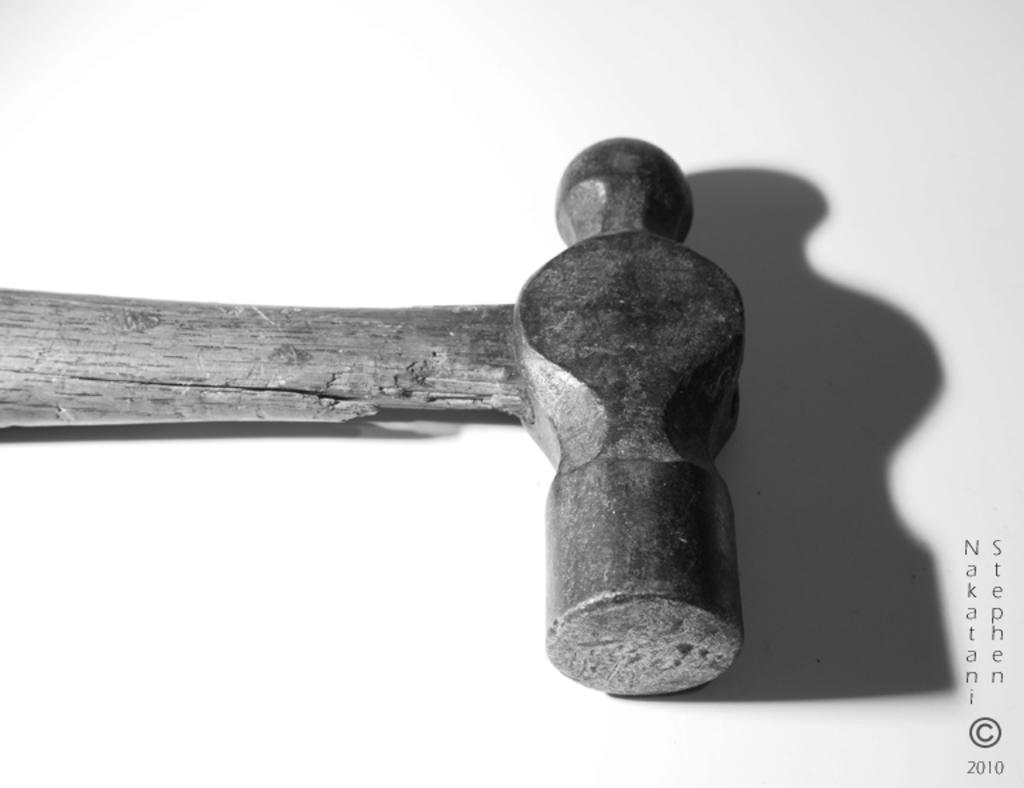What object can be seen in the image? There is a hammer in the image. What else is present in the image besides the hammer? There is text and numbers in the image. Where are the text and numbers located in the image? The text and numbers are located on the bottom right side of the image. What is the color of the background in the image? The background of the image is white. What type of zinc is used to write the text in the image? There is no zinc present in the image, and the text is not written by hand. --- Facts: 1. There is a person sitting on a chair in the image. 2. The person is holding a book. 3. The book has a blue cover. 4. There is a table next to the chair. 5. The table has a lamp on it. Absurd Topics: elephant, ocean, bicycle Conversation: What is the person in the image doing? The person is sitting on a chair in the image. What is the person holding in the image? The person is holding a book in the image. What color is the book's cover? The book has a blue cover. What is located next to the chair in the image? There is a table next to the chair in the image. What is on the table in the image? The table has a lamp on it. Reasoning: Let's think step by step in order to produce the conversation. We start by identifying the main subject in the image, which is the person sitting on a chair. Then, we expand the conversation to include other elements that are also visible, such as the book, the book's cover color, the table, and the lamp. Each question is designed to elicit a specific detail about the image that is known from the provided facts. Absurd Question/Answer: Can you see an elephant swimming in the ocean in the image? No, there is no elephant or ocean present in the image. 